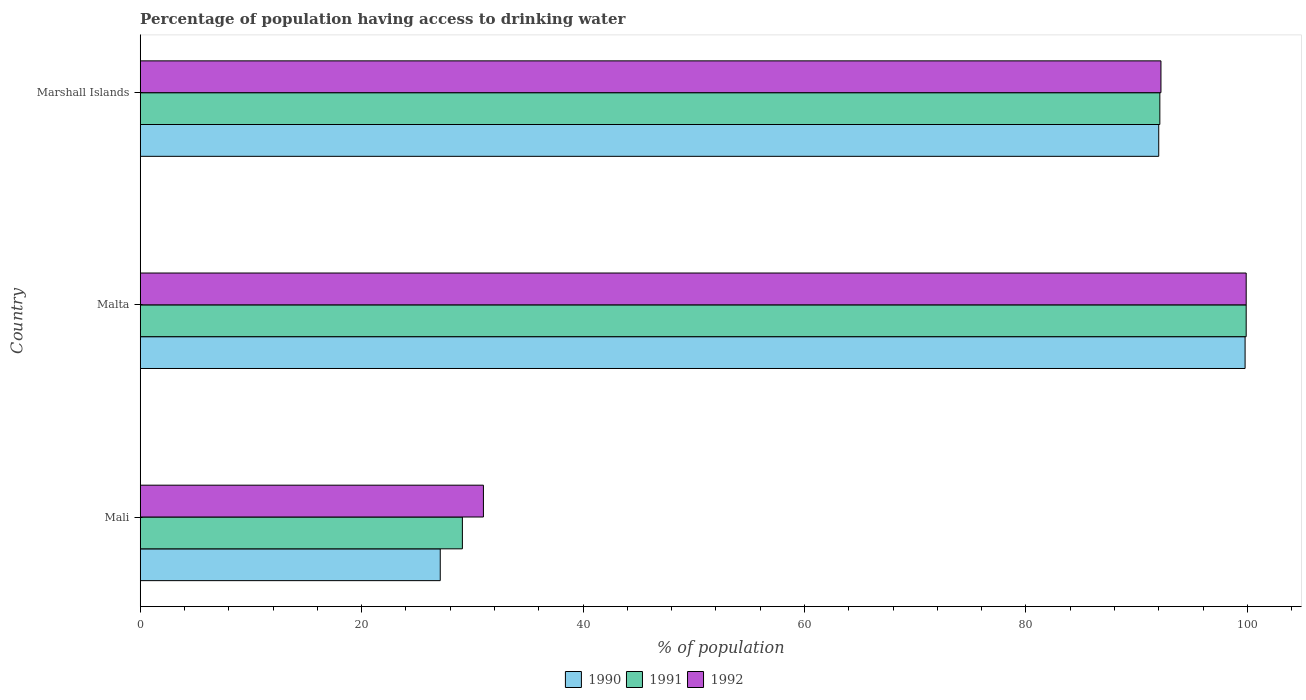Are the number of bars on each tick of the Y-axis equal?
Provide a succinct answer. Yes. How many bars are there on the 2nd tick from the bottom?
Keep it short and to the point. 3. What is the label of the 1st group of bars from the top?
Provide a short and direct response. Marshall Islands. In how many cases, is the number of bars for a given country not equal to the number of legend labels?
Keep it short and to the point. 0. What is the percentage of population having access to drinking water in 1990 in Marshall Islands?
Make the answer very short. 92. Across all countries, what is the maximum percentage of population having access to drinking water in 1990?
Offer a terse response. 99.8. Across all countries, what is the minimum percentage of population having access to drinking water in 1992?
Your answer should be compact. 31. In which country was the percentage of population having access to drinking water in 1990 maximum?
Provide a short and direct response. Malta. In which country was the percentage of population having access to drinking water in 1990 minimum?
Keep it short and to the point. Mali. What is the total percentage of population having access to drinking water in 1991 in the graph?
Your answer should be very brief. 221.1. What is the difference between the percentage of population having access to drinking water in 1992 in Malta and that in Marshall Islands?
Make the answer very short. 7.7. What is the difference between the percentage of population having access to drinking water in 1990 in Marshall Islands and the percentage of population having access to drinking water in 1992 in Mali?
Your response must be concise. 61. What is the average percentage of population having access to drinking water in 1990 per country?
Your answer should be compact. 72.97. What is the ratio of the percentage of population having access to drinking water in 1992 in Malta to that in Marshall Islands?
Offer a terse response. 1.08. Is the percentage of population having access to drinking water in 1992 in Mali less than that in Malta?
Ensure brevity in your answer.  Yes. What is the difference between the highest and the second highest percentage of population having access to drinking water in 1991?
Offer a very short reply. 7.8. What is the difference between the highest and the lowest percentage of population having access to drinking water in 1992?
Ensure brevity in your answer.  68.9. What does the 2nd bar from the bottom in Marshall Islands represents?
Provide a succinct answer. 1991. What is the difference between two consecutive major ticks on the X-axis?
Your answer should be very brief. 20. Are the values on the major ticks of X-axis written in scientific E-notation?
Ensure brevity in your answer.  No. Where does the legend appear in the graph?
Provide a succinct answer. Bottom center. How are the legend labels stacked?
Ensure brevity in your answer.  Horizontal. What is the title of the graph?
Your answer should be compact. Percentage of population having access to drinking water. What is the label or title of the X-axis?
Your answer should be very brief. % of population. What is the label or title of the Y-axis?
Ensure brevity in your answer.  Country. What is the % of population in 1990 in Mali?
Provide a short and direct response. 27.1. What is the % of population in 1991 in Mali?
Provide a short and direct response. 29.1. What is the % of population in 1990 in Malta?
Ensure brevity in your answer.  99.8. What is the % of population in 1991 in Malta?
Your answer should be compact. 99.9. What is the % of population of 1992 in Malta?
Keep it short and to the point. 99.9. What is the % of population of 1990 in Marshall Islands?
Provide a succinct answer. 92. What is the % of population of 1991 in Marshall Islands?
Provide a succinct answer. 92.1. What is the % of population of 1992 in Marshall Islands?
Your response must be concise. 92.2. Across all countries, what is the maximum % of population of 1990?
Keep it short and to the point. 99.8. Across all countries, what is the maximum % of population in 1991?
Provide a succinct answer. 99.9. Across all countries, what is the maximum % of population of 1992?
Ensure brevity in your answer.  99.9. Across all countries, what is the minimum % of population in 1990?
Provide a succinct answer. 27.1. Across all countries, what is the minimum % of population in 1991?
Keep it short and to the point. 29.1. Across all countries, what is the minimum % of population in 1992?
Your response must be concise. 31. What is the total % of population in 1990 in the graph?
Keep it short and to the point. 218.9. What is the total % of population of 1991 in the graph?
Provide a succinct answer. 221.1. What is the total % of population of 1992 in the graph?
Ensure brevity in your answer.  223.1. What is the difference between the % of population of 1990 in Mali and that in Malta?
Your answer should be compact. -72.7. What is the difference between the % of population of 1991 in Mali and that in Malta?
Offer a terse response. -70.8. What is the difference between the % of population in 1992 in Mali and that in Malta?
Your response must be concise. -68.9. What is the difference between the % of population of 1990 in Mali and that in Marshall Islands?
Keep it short and to the point. -64.9. What is the difference between the % of population in 1991 in Mali and that in Marshall Islands?
Your response must be concise. -63. What is the difference between the % of population of 1992 in Mali and that in Marshall Islands?
Make the answer very short. -61.2. What is the difference between the % of population of 1990 in Malta and that in Marshall Islands?
Provide a short and direct response. 7.8. What is the difference between the % of population in 1990 in Mali and the % of population in 1991 in Malta?
Ensure brevity in your answer.  -72.8. What is the difference between the % of population in 1990 in Mali and the % of population in 1992 in Malta?
Keep it short and to the point. -72.8. What is the difference between the % of population of 1991 in Mali and the % of population of 1992 in Malta?
Offer a terse response. -70.8. What is the difference between the % of population of 1990 in Mali and the % of population of 1991 in Marshall Islands?
Keep it short and to the point. -65. What is the difference between the % of population in 1990 in Mali and the % of population in 1992 in Marshall Islands?
Keep it short and to the point. -65.1. What is the difference between the % of population in 1991 in Mali and the % of population in 1992 in Marshall Islands?
Give a very brief answer. -63.1. What is the difference between the % of population of 1991 in Malta and the % of population of 1992 in Marshall Islands?
Keep it short and to the point. 7.7. What is the average % of population of 1990 per country?
Offer a terse response. 72.97. What is the average % of population in 1991 per country?
Your answer should be compact. 73.7. What is the average % of population in 1992 per country?
Offer a terse response. 74.37. What is the difference between the % of population in 1990 and % of population in 1991 in Malta?
Make the answer very short. -0.1. What is the difference between the % of population in 1991 and % of population in 1992 in Malta?
Your answer should be compact. 0. What is the difference between the % of population of 1990 and % of population of 1991 in Marshall Islands?
Provide a succinct answer. -0.1. What is the ratio of the % of population of 1990 in Mali to that in Malta?
Your response must be concise. 0.27. What is the ratio of the % of population of 1991 in Mali to that in Malta?
Offer a very short reply. 0.29. What is the ratio of the % of population of 1992 in Mali to that in Malta?
Give a very brief answer. 0.31. What is the ratio of the % of population in 1990 in Mali to that in Marshall Islands?
Provide a short and direct response. 0.29. What is the ratio of the % of population in 1991 in Mali to that in Marshall Islands?
Offer a terse response. 0.32. What is the ratio of the % of population in 1992 in Mali to that in Marshall Islands?
Offer a terse response. 0.34. What is the ratio of the % of population of 1990 in Malta to that in Marshall Islands?
Keep it short and to the point. 1.08. What is the ratio of the % of population in 1991 in Malta to that in Marshall Islands?
Your answer should be compact. 1.08. What is the ratio of the % of population in 1992 in Malta to that in Marshall Islands?
Offer a very short reply. 1.08. What is the difference between the highest and the lowest % of population of 1990?
Keep it short and to the point. 72.7. What is the difference between the highest and the lowest % of population in 1991?
Provide a short and direct response. 70.8. What is the difference between the highest and the lowest % of population in 1992?
Make the answer very short. 68.9. 